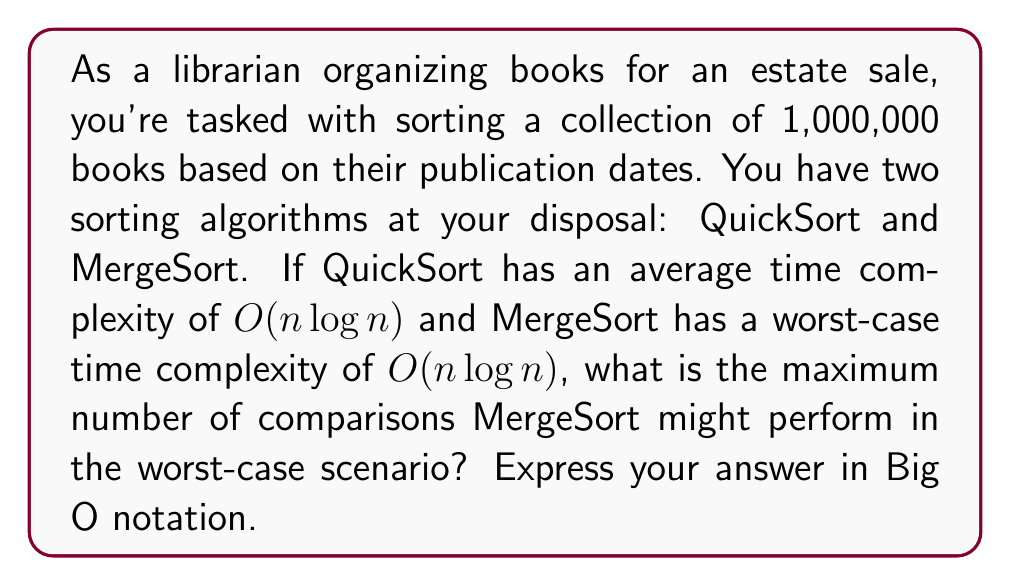Help me with this question. To solve this problem, let's break it down step-by-step:

1. We're dealing with MergeSort's worst-case time complexity, which is $O(n \log n)$.

2. The number of books, n, is 1,000,000.

3. In Big O notation, we're interested in the order of growth, not the exact number of operations. However, to understand the scale, we can calculate an upper bound on the number of comparisons.

4. For MergeSort, the worst-case number of comparisons is approximately $n \log_2 n$.

5. Let's calculate this:
   $$n \log_2 n = 1,000,000 \cdot \log_2(1,000,000)$$
   
   $$\log_2(1,000,000) \approx 19.93$$
   
   $$1,000,000 \cdot 19.93 \approx 19,930,000$$

6. This means MergeSort might perform up to about 19,930,000 comparisons in the worst case.

7. However, in Big O notation, we express this as $O(n \log n)$, which represents the order of growth rather than the exact number of operations.

Therefore, the maximum number of comparisons MergeSort might perform in the worst-case scenario, expressed in Big O notation, remains $O(n \log n)$.
Answer: $O(n \log n)$ 